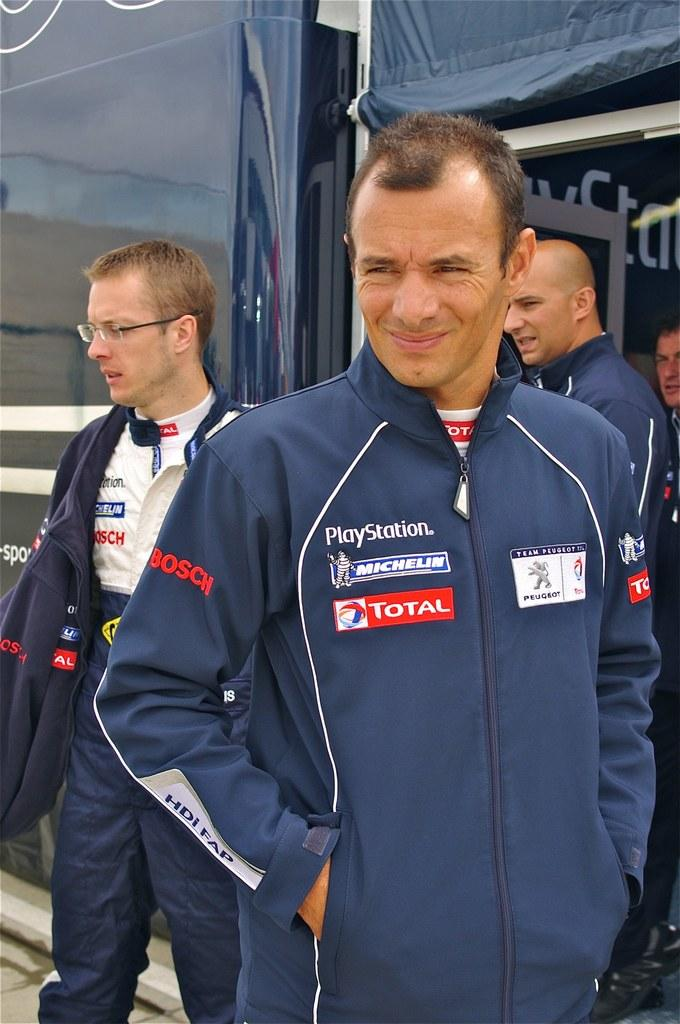<image>
Describe the image concisely. A man smiles for the camera in a coat that is sponsored by Playstation, Michelin, and Total. 